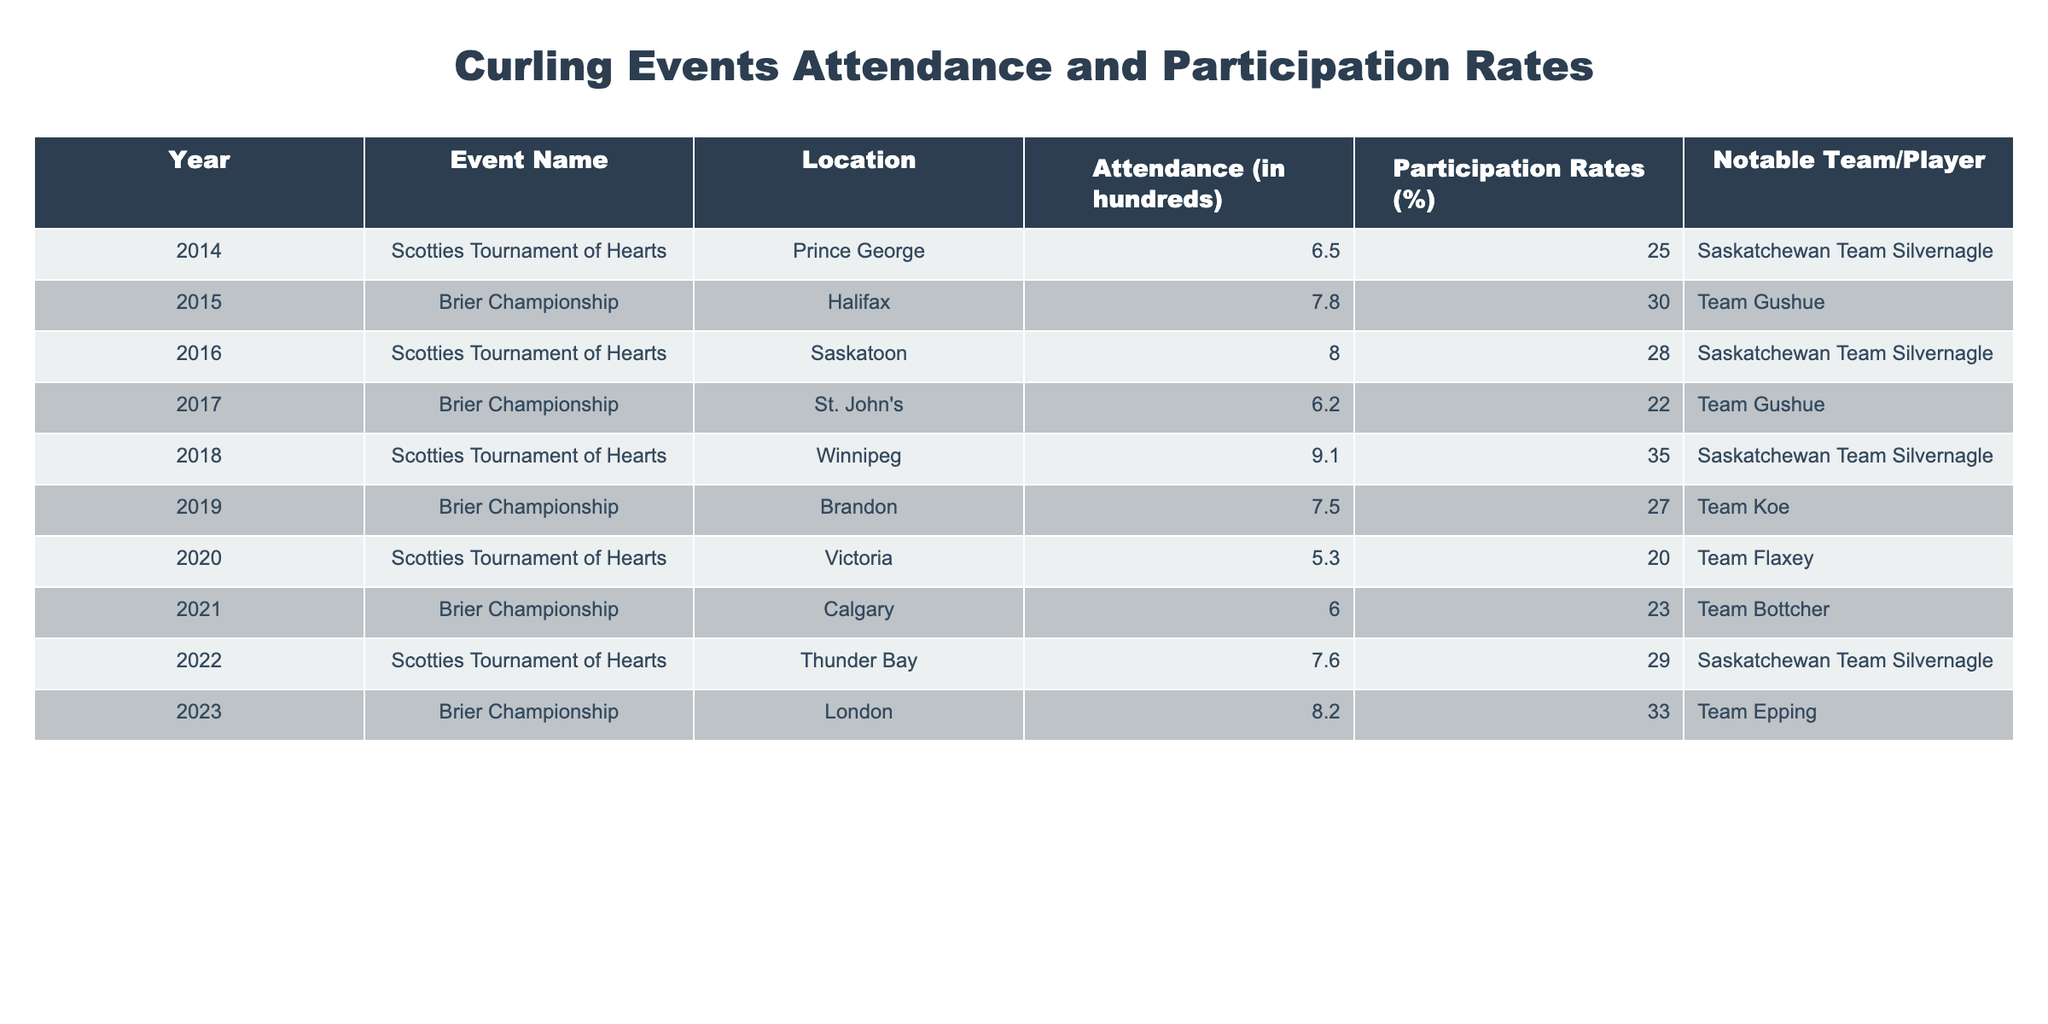What was the highest attendance recorded at a curling event from 2014 to 2023? Reviewing the Attendance column, the highest value is 9.1 which corresponds to the Scotties Tournament of Hearts in Winnipeg in 2018.
Answer: 9.1 Which event had the lowest participation rate and what was that rate? Looking at the Participation Rates column, the lowest percentage is 20, observed at the Scotties Tournament of Hearts in Victoria in 2020.
Answer: 20 What is the average attendance across all the events listed? To find the average attendance, add all attendance values (6.5 + 7.8 + 8.0 + 6.2 + 9.1 + 7.5 + 5.3 + 6.0 + 7.6 + 8.2 = 66.2), then divide by the number of events (10), resulting in an average of 6.62 hundreds, or 662.
Answer: 6.62 Did participation rates in the Scotties Tournament of Hearts generally increase over the decade? By comparing the Participation Rates of Scotties events: 25 (2014), 28 (2016), 35 (2018), 29 (2022), we see that they went up from 2014 to 2018, then had a slight decrease to 29 in 2022. Therefore, generally, it increased initially but then fluctuated.
Answer: No How many times was Saskatchewan Team Silvernagle highlighted in events during this period? By scanning the Notable Team/Player column, Saskatchewan Team Silvernagle is mentioned four times (2014, 2016, 2018, 2022).
Answer: 4 What is the difference in participation rates between the highest and lowest recorded events? The highest participation rate is 35 (Scotties 2018) and the lowest is 20 (Scotties 2020). The difference is 35 - 20 = 15.
Answer: 15 Which event has the highest participation rate and what team was notable in that event? The event with the highest participation rate is the Scotties Tournament of Hearts in 2018 with a participation rate of 35%, and the notable team that year was Saskatchewan Team Silvernagle.
Answer: 35%, Saskatchewan Team Silvernagle In which year did the Brier Championship have an attendance higher than the average attendance calculated? The average attendance calculated was 6.62 hundreds. Checking against the Brier years: Attendance values are 7.8 (2015), 6.2 (2017), 6.0 (2021), and 8.2 (2023). The years 2015 and 2023 had higher attendance than the average.
Answer: 2015, 2023 Was there a year when both participation and attendance were the lowest? Analyzing the table, the Scotties in Victoria in 2020 had the lowest attendance at 5.3 and a participation rate of 20, confirming that both figures were at their lowest in this year.
Answer: Yes For which event did Team Gushue participate, and how did the participation rate compare to the average? Team Gushue participated in the Brier Championship in 2015, with a participation rate of 30. Comparing this with the average participation rate (which can be calculated as the average of the rates listed), we find that 30 is above the average participation rate of 26.5%.
Answer: Brier Championship 2015, above average 